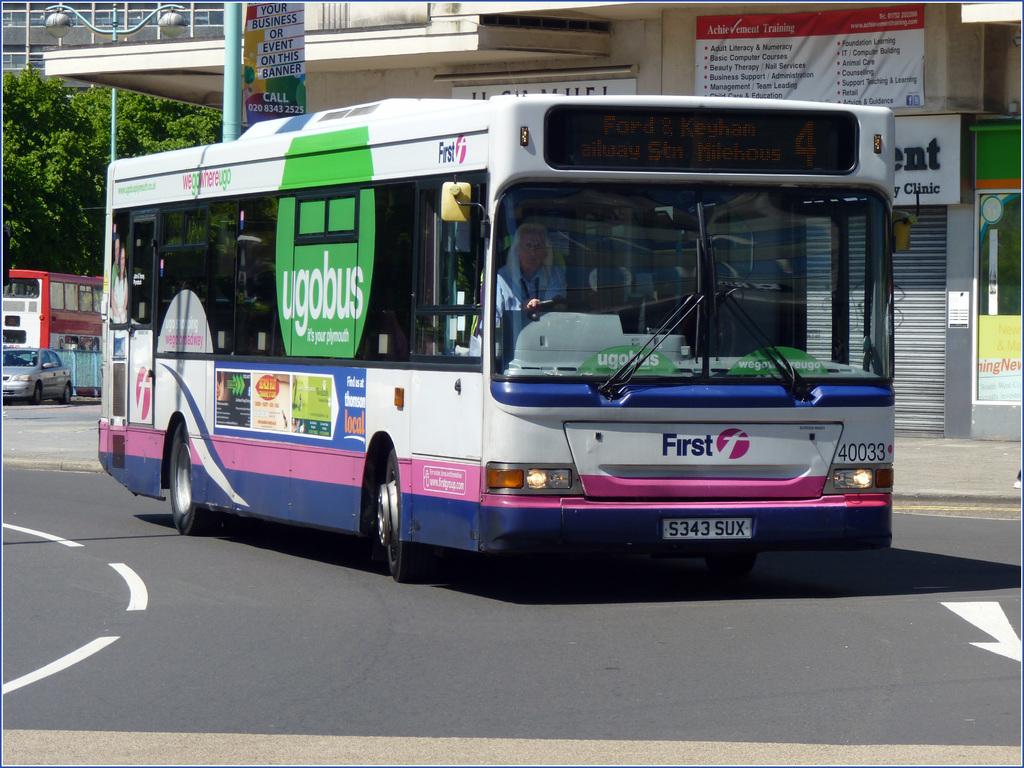What is the name of the bus company?
Your response must be concise. First. 